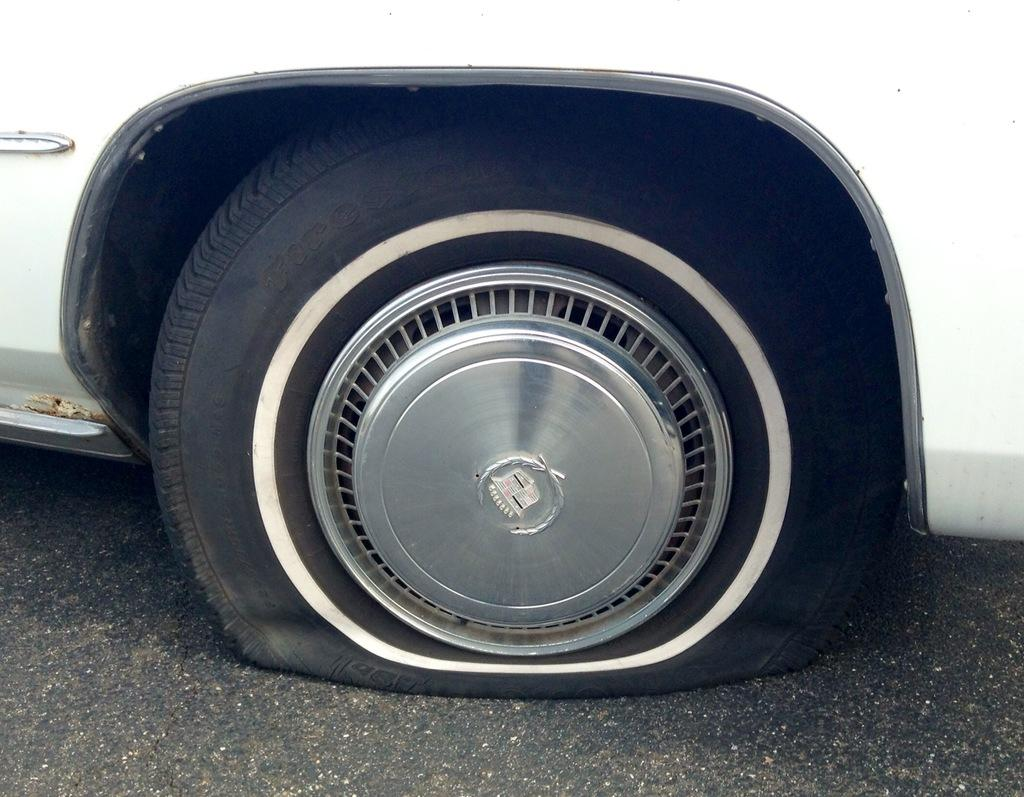What type of vehicle is in the picture? There is a white car in the picture. What is the condition of the car's tyre? The car has a punctured tyre. Where is the punctured tyre located in the picture? The tyre is in the middle of the picture. What can be seen beneath the car in the image? The road is visible at the bottom of the picture. What type of nerve can be seen in the picture? There is no nerve present in the picture; it features a white car with a punctured tyre and a visible road. What effect does the tin have on the car in the image? There is no tin present in the image, so it cannot have any effect on the car. 